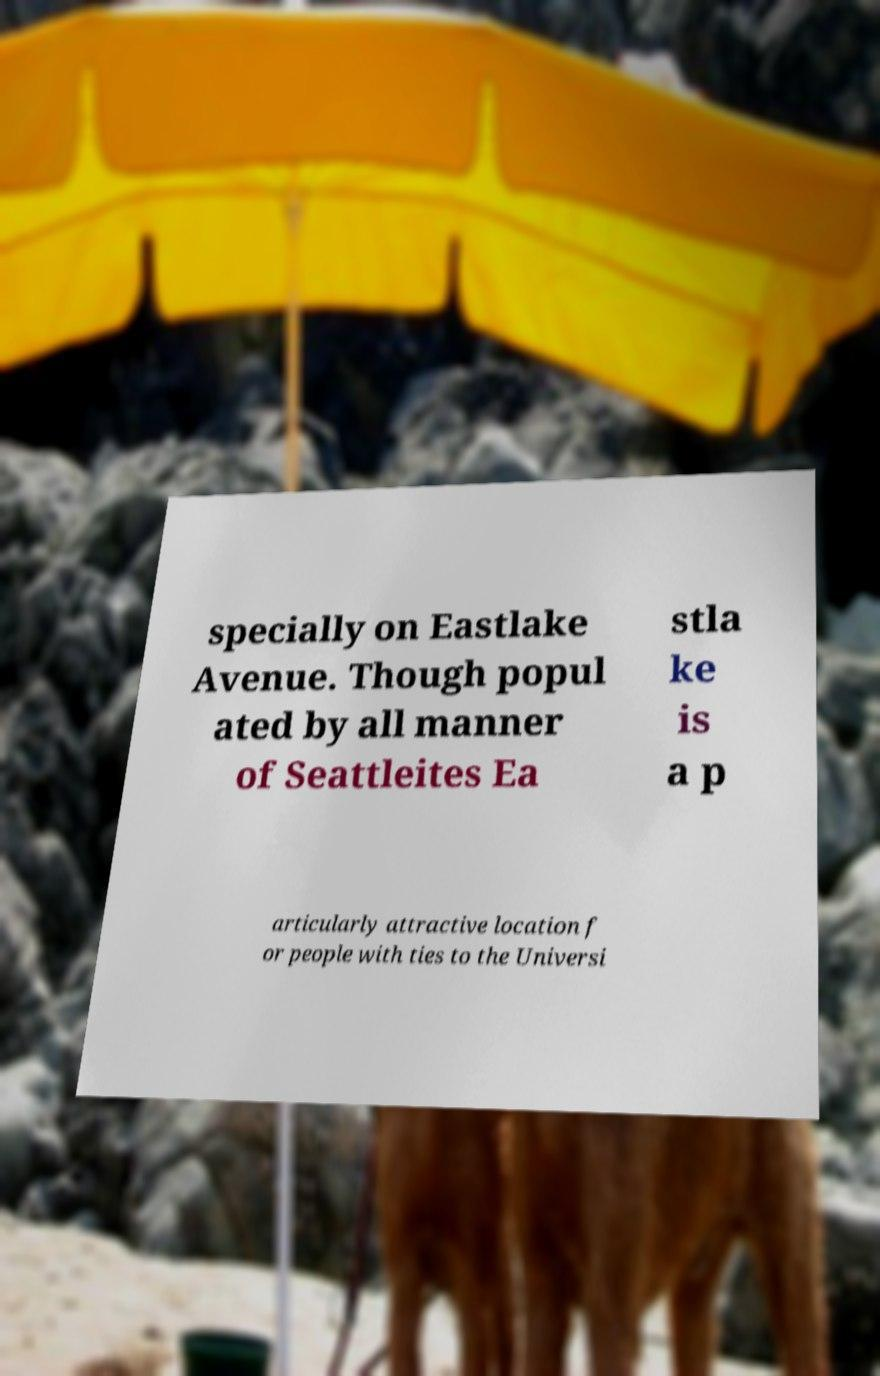Please read and relay the text visible in this image. What does it say? specially on Eastlake Avenue. Though popul ated by all manner of Seattleites Ea stla ke is a p articularly attractive location f or people with ties to the Universi 